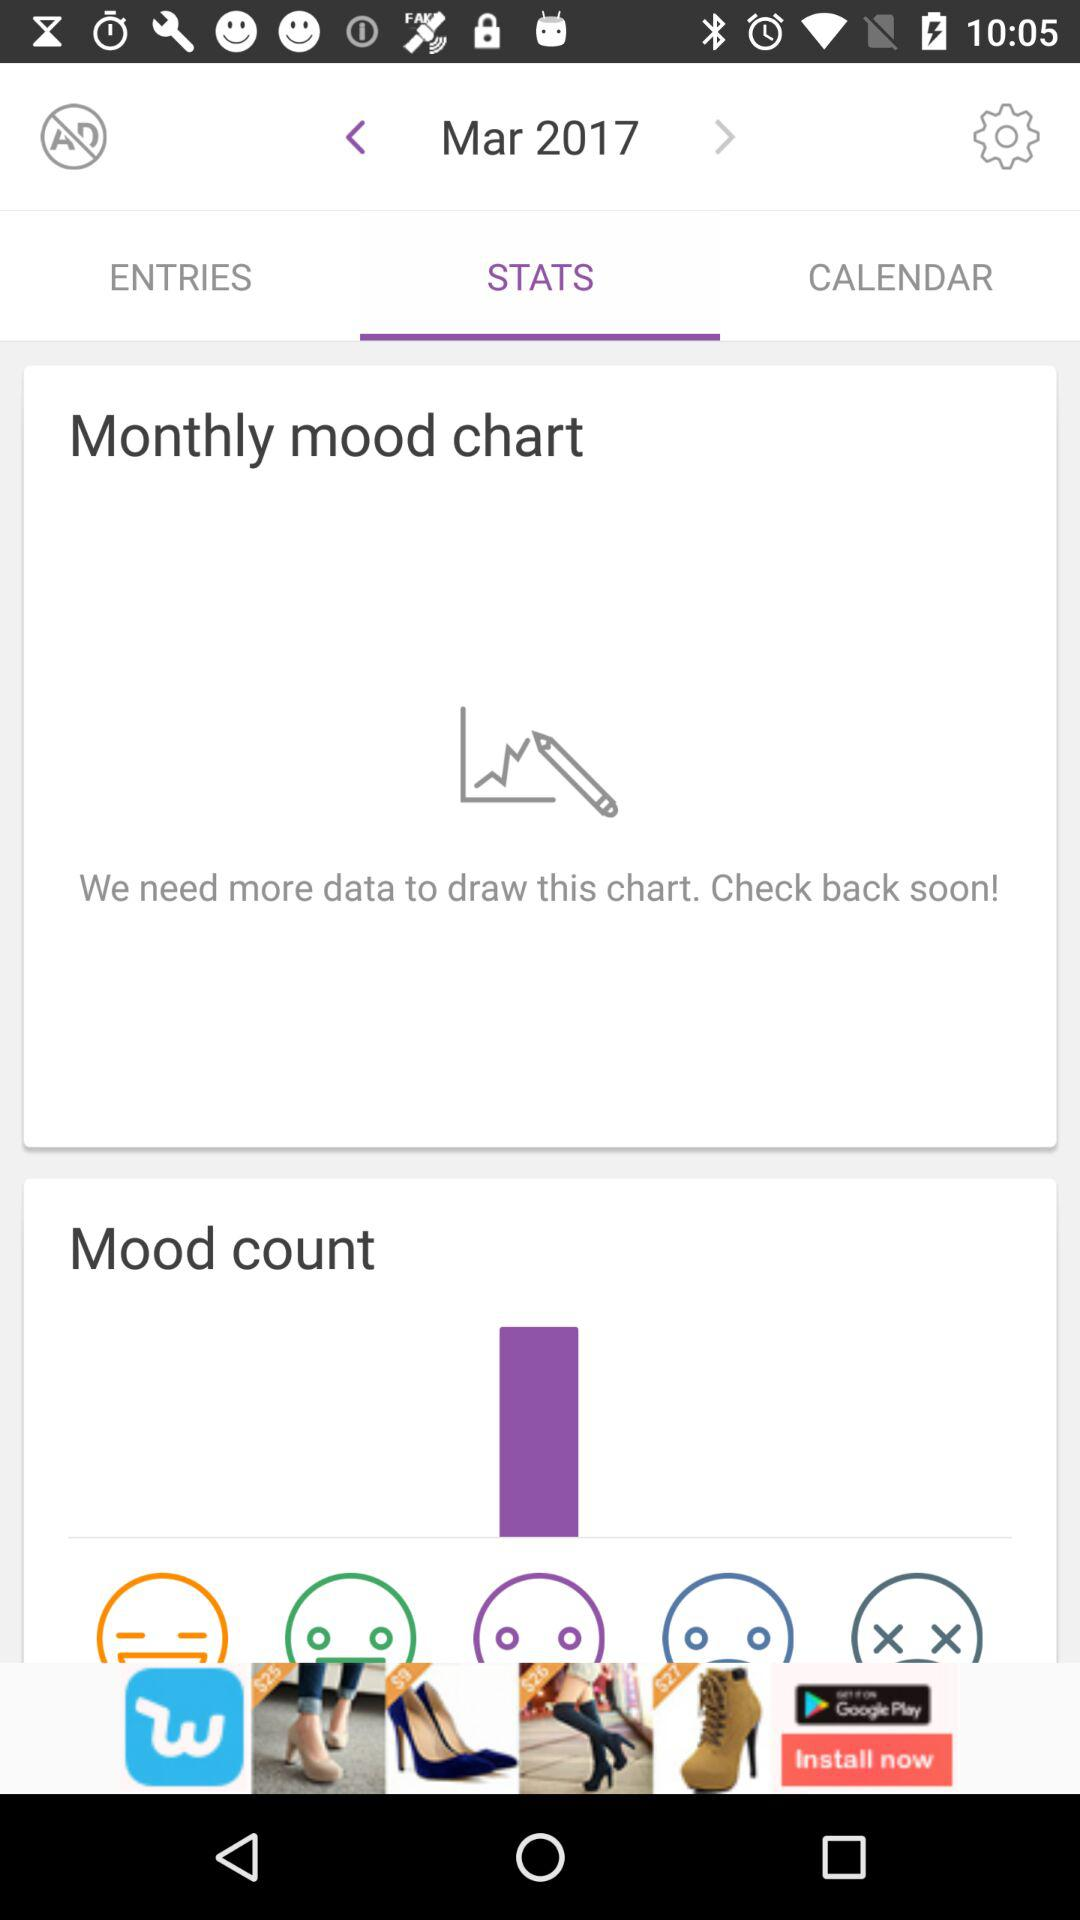Which year is selected? The selected year is 2017. 